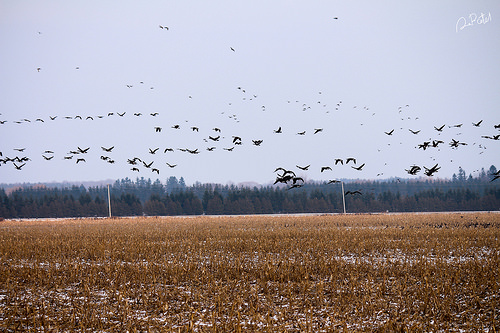<image>
Is there a bird on the grass? No. The bird is not positioned on the grass. They may be near each other, but the bird is not supported by or resting on top of the grass. Where is the sky in relation to the tree? Is it behind the tree? Yes. From this viewpoint, the sky is positioned behind the tree, with the tree partially or fully occluding the sky. Is there a bird above the ground? Yes. The bird is positioned above the ground in the vertical space, higher up in the scene. 